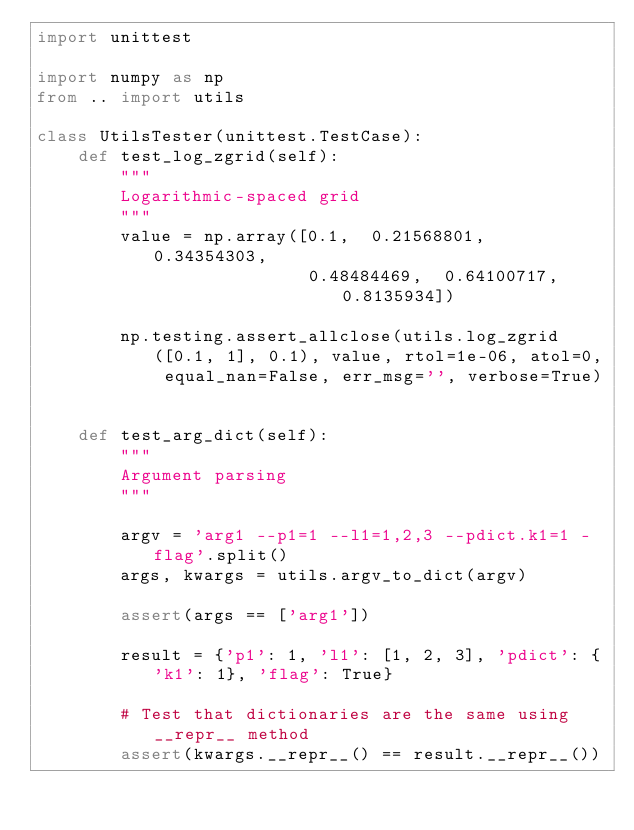Convert code to text. <code><loc_0><loc_0><loc_500><loc_500><_Python_>import unittest

import numpy as np
from .. import utils

class UtilsTester(unittest.TestCase):
    def test_log_zgrid(self):
        """
        Logarithmic-spaced grid
        """
        value = np.array([0.1,  0.21568801,  0.34354303,  
                          0.48484469,  0.64100717, 0.8135934])
                          
        np.testing.assert_allclose(utils.log_zgrid([0.1, 1], 0.1), value, rtol=1e-06, atol=0, equal_nan=False, err_msg='', verbose=True)
    
    
    def test_arg_dict(self):
        """
        Argument parsing
        """
        
        argv = 'arg1 --p1=1 --l1=1,2,3 --pdict.k1=1 -flag'.split()
        args, kwargs = utils.argv_to_dict(argv)
        
        assert(args == ['arg1'])
        
        result = {'p1': 1, 'l1': [1, 2, 3], 'pdict': {'k1': 1}, 'flag': True}
        
        # Test that dictionaries are the same using __repr__ method
        assert(kwargs.__repr__() == result.__repr__())
                
        </code> 